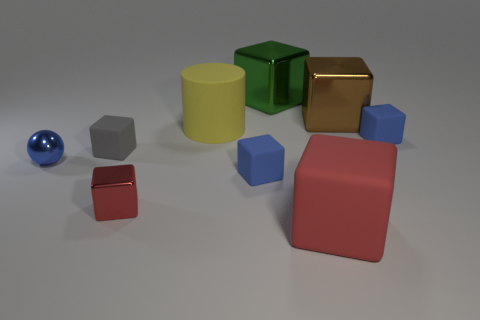What is the big block that is both to the right of the large green metal object and behind the red matte object made of?
Your answer should be very brief. Metal. What is the shape of the big red thing that is made of the same material as the gray cube?
Your response must be concise. Cube. There is a tiny blue object that is behind the tiny blue metal ball; how many shiny blocks are in front of it?
Make the answer very short. 1. What number of big blocks are in front of the green metallic object and behind the small gray rubber cube?
Provide a short and direct response. 1. How many other objects are the same material as the large red cube?
Your answer should be very brief. 4. There is a tiny metallic object that is behind the tiny matte thing that is in front of the small gray rubber cube; what color is it?
Your response must be concise. Blue. Does the tiny cube right of the green object have the same color as the shiny sphere?
Your response must be concise. Yes. Does the brown metallic object have the same size as the green block?
Give a very brief answer. Yes. There is a brown metallic thing that is the same size as the yellow cylinder; what is its shape?
Your response must be concise. Cube. Does the matte object that is left of the red shiny cube have the same size as the green metal object?
Provide a succinct answer. No. 